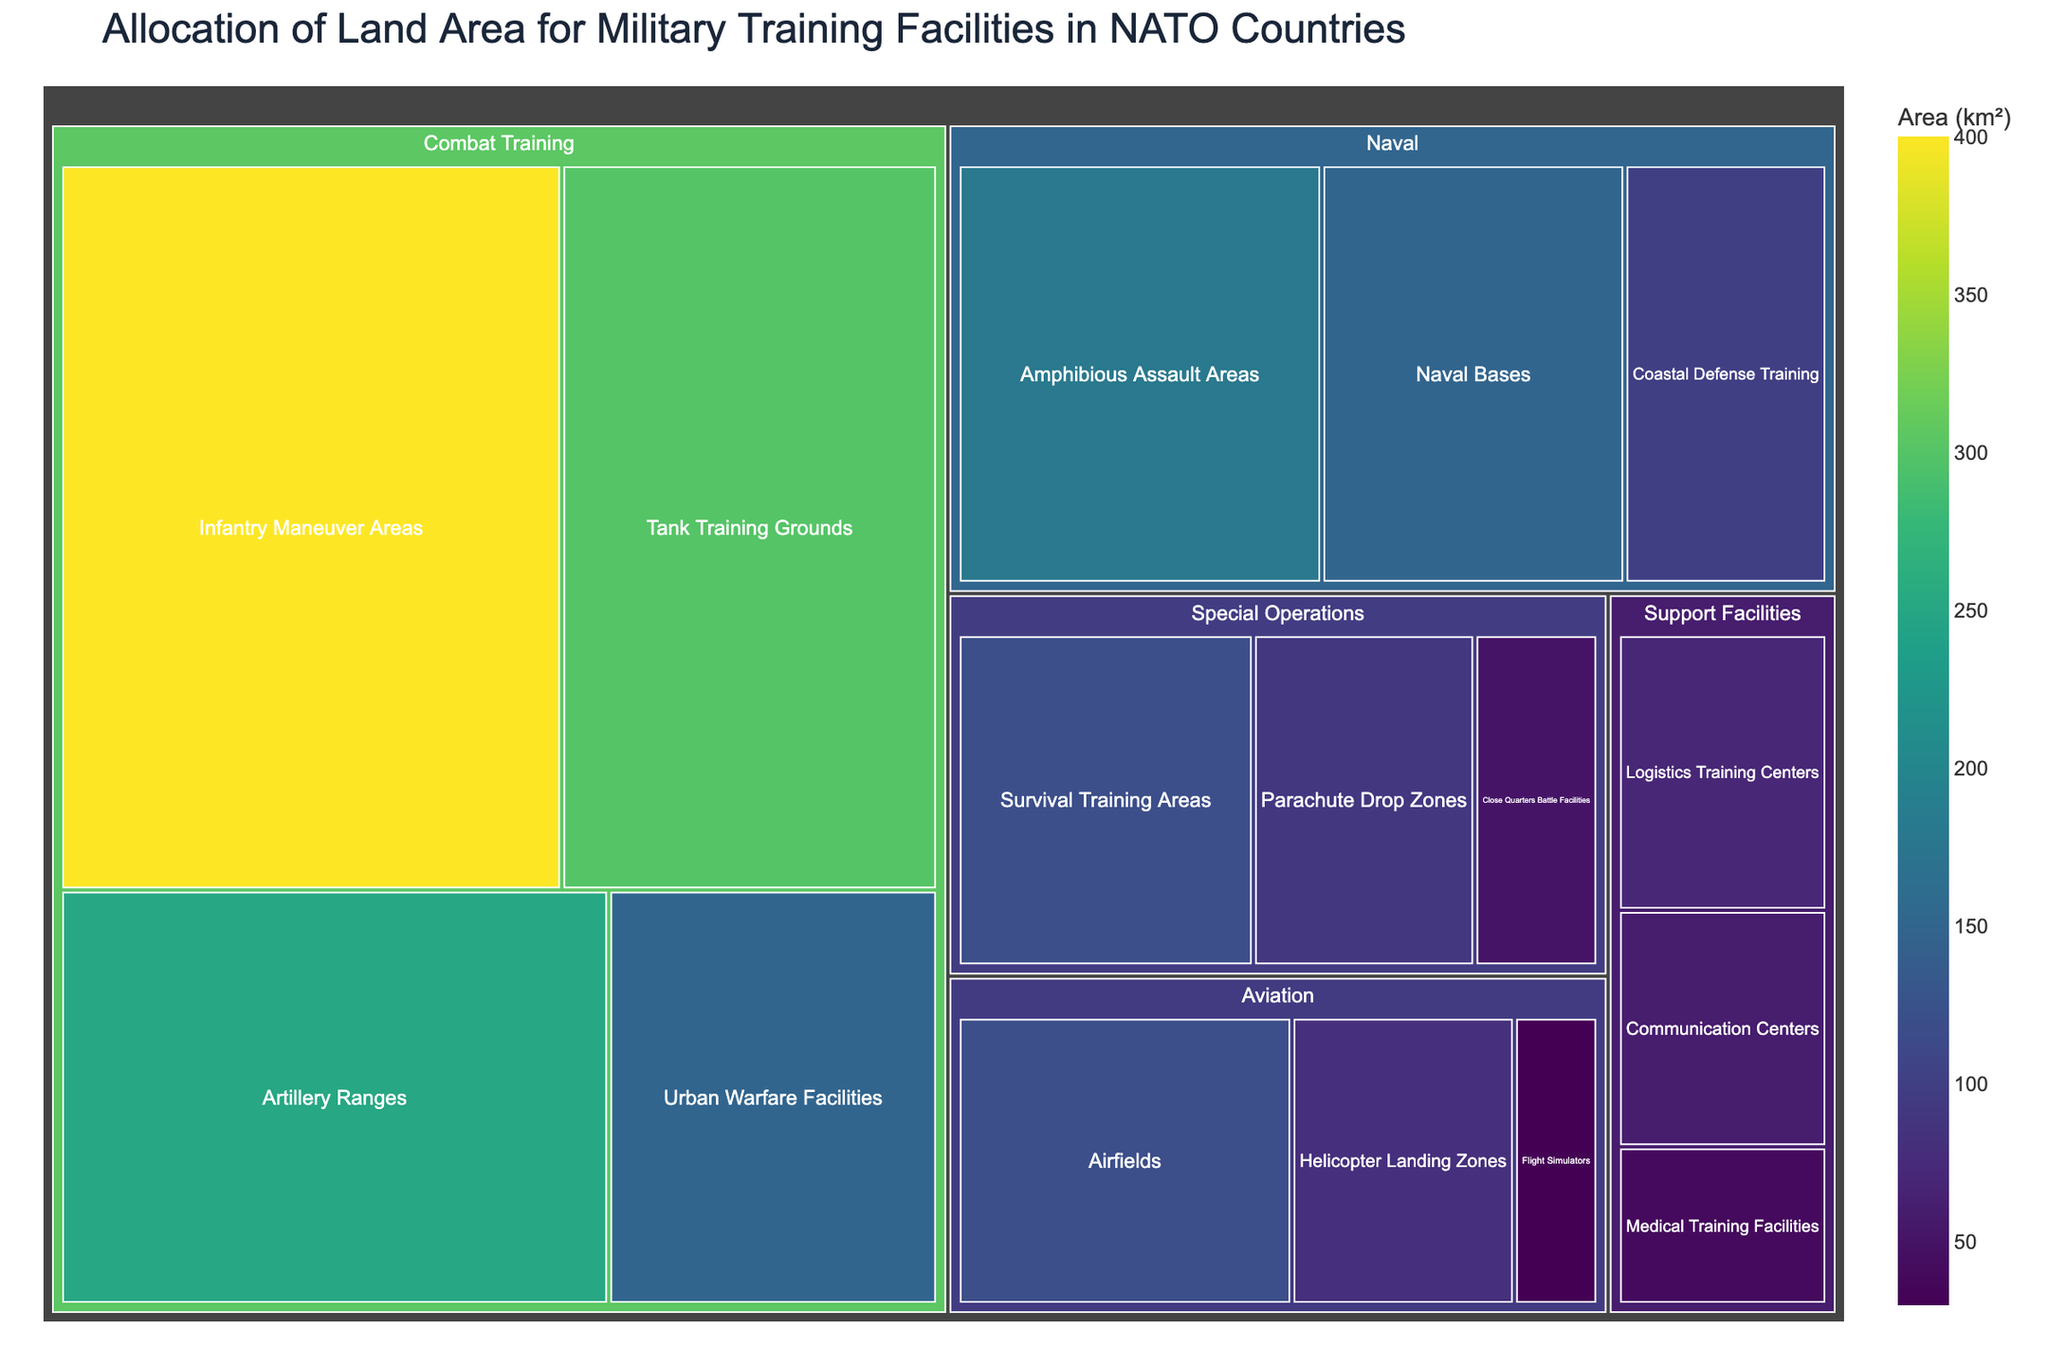What's the title of the Treemap? The title is usually the largest text at the top of the figure and it provides a brief description of the content. Here, look for a descriptive phrase that encapsulates the main topic of the Treemap.
Answer: Allocation of Land Area for Military Training Facilities in NATO Countries Which subcategory in the Combat Training category has the largest area? Within the Combat Training category, look for the subcategory that occupies the most space. The larger the area on the Treemap, the larger the value it represents.
Answer: Infantry Maneuver Areas What is the total area allocated for Special Operations training facilities? To find the total area for Special Operations, sum up the areas of all its subcategories. The subcategories are Close Quarters Battle Facilities (50 km²), Survival Training Areas (120 km²), and Parachute Drop Zones (90 km²). The sum is 50 + 120 + 90.
Answer: 260 km² Which category has the largest total land area allocated? Identify the category with the largest combined area. Visually, this will be the category with the most combined space in the Treemap. Compare the areas of Combat Training, Aviation, Naval, Special Operations, and Support Facilities.
Answer: Combat Training How does the land area allocated for Airfields compare to that for Helicopter Landing Zones? Compare the size of the areas for Airfields and Helicopter Landing Zones by visually inspecting the relative sizes or checking the provided data. Airfields have 120 km², and Helicopter Landing Zones have 80 km².
Answer: Airfields have a larger area What's the total area allocated for support facilities? Add up the areas of all subcategories in the Support Facilities category. The subcategories are Logistics Training Centers (70 km²), Medical Training Facilities (40 km²), and Communication Centers (60 km²). Sum them: 70 + 40 + 60 = 170.
Answer: 170 km² Which category has the smallest area allocated, and what is it? Visually inspect the Treemap to identify the category with the smallest combined area. Check the data for confirmation.
Answer: Support Facilities, 170 km² Out of Naval Bases and Amphibious Assault Areas, which has a larger area? Compare the sizes of the areas allocated to Naval Bases (150 km²) and Amphibious Assault Areas (180 km²). From the larger space in the Treemap, you can infer the larger area.
Answer: Amphibious Assault Areas What's the combined area for Coastal Defense Training and Amphibious Assault Areas? To find this, add the areas of these two subcategories: Coastal Defense Training (100 km²) and Amphibious Assault Areas (180 km²). The sum is 100 + 180.
Answer: 280 km² If you merge the areas for Urban Warfare Facilities and Artillery Ranges, how does it compare to Tank Training Grounds? Sum the areas of Urban Warfare Facilities (150 km²) and Artillery Ranges (250 km²): 150 + 250 = 400. Then compare this to Tank Training Grounds (300 km²).
Answer: Urban Warfare and Artillery combined are larger 